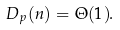Convert formula to latex. <formula><loc_0><loc_0><loc_500><loc_500>D _ { p } ( n ) = \Theta ( 1 ) .</formula> 